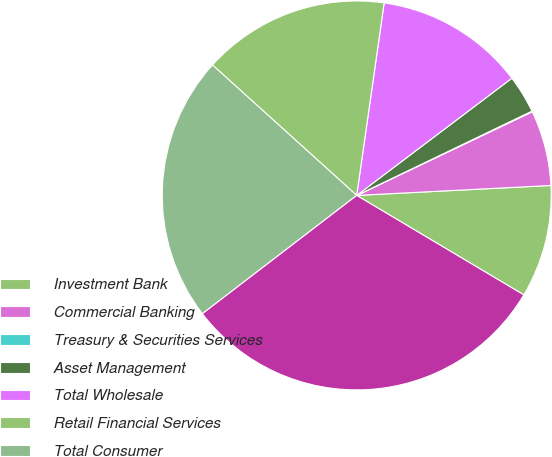Convert chart to OTSL. <chart><loc_0><loc_0><loc_500><loc_500><pie_chart><fcel>Investment Bank<fcel>Commercial Banking<fcel>Treasury & Securities Services<fcel>Asset Management<fcel>Total Wholesale<fcel>Retail Financial Services<fcel>Total Consumer<fcel>Total provision for credit<nl><fcel>9.36%<fcel>6.26%<fcel>0.06%<fcel>3.16%<fcel>12.45%<fcel>15.55%<fcel>22.11%<fcel>31.04%<nl></chart> 